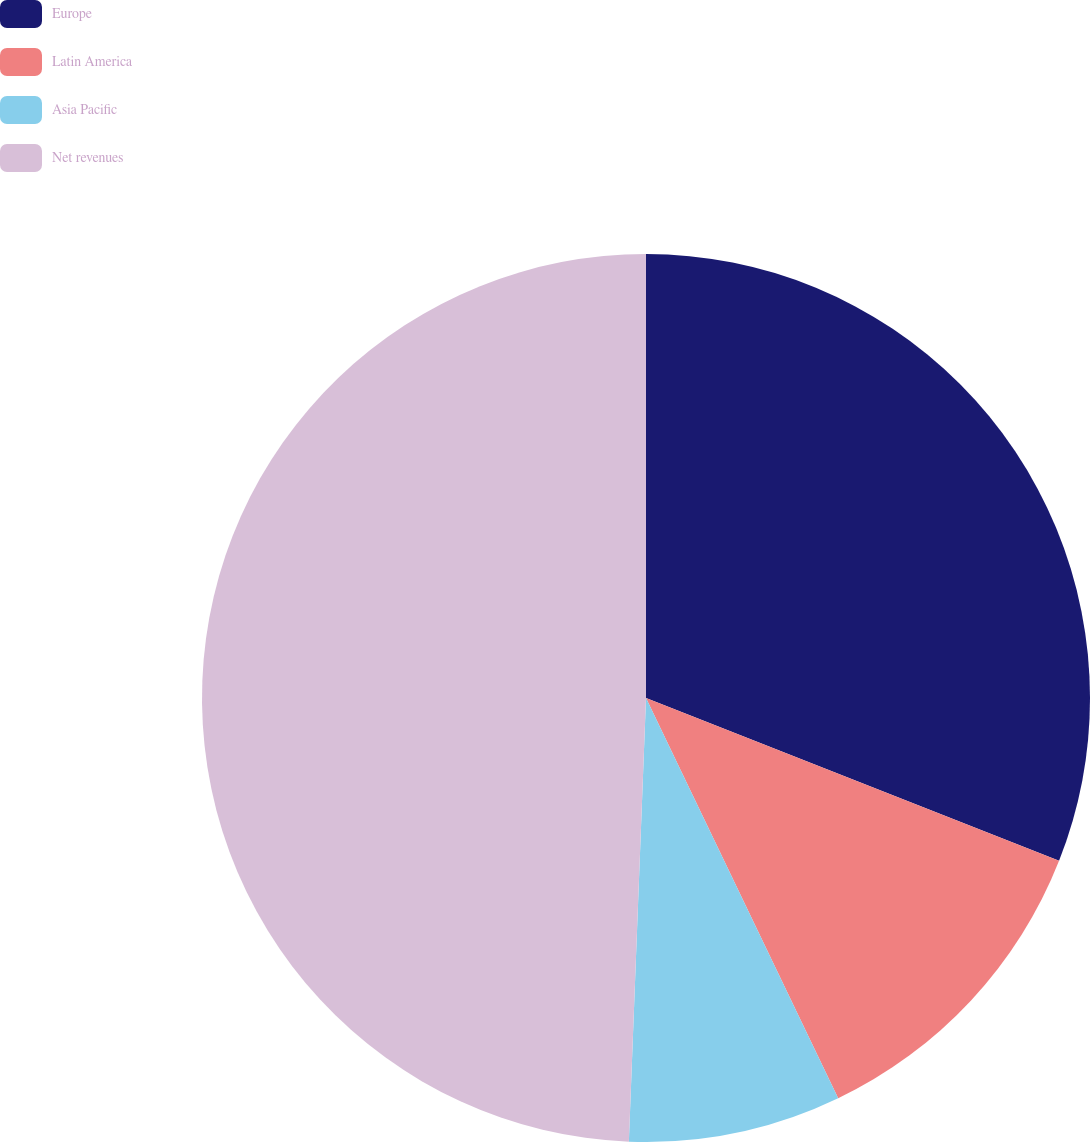Convert chart to OTSL. <chart><loc_0><loc_0><loc_500><loc_500><pie_chart><fcel>Europe<fcel>Latin America<fcel>Asia Pacific<fcel>Net revenues<nl><fcel>30.98%<fcel>11.9%<fcel>7.74%<fcel>49.39%<nl></chart> 